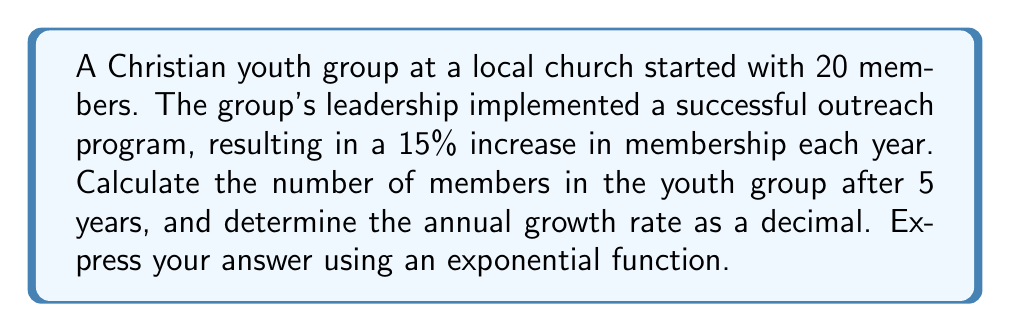Help me with this question. To solve this problem, we'll use an exponential growth function and follow these steps:

1. Identify the components of the exponential growth function:
   $A = P(1 + r)^t$
   Where:
   $A$ = Final amount
   $P$ = Initial principal (starting amount)
   $r$ = Annual growth rate (as a decimal)
   $t$ = Time in years

2. Fill in the known values:
   $P = 20$ (initial members)
   $r = 0.15$ (15% growth rate as a decimal)
   $t = 5$ (years)

3. Plug these values into the exponential growth function:
   $A = 20(1 + 0.15)^5$

4. Simplify:
   $A = 20(1.15)^5$

5. Calculate the result:
   $A = 20 * 2.0113689 \approx 40.23$ (rounded to two decimal places)

To express the answer using an exponential function, we keep it in the form:
$A = 20(1.15)^t$

Where $t$ represents the number of years since the program started.

The annual growth rate as a decimal is 0.15, which was given in the problem.
Answer: The number of members after 5 years: $A \approx 40.23$
The exponential function representing the growth: $A = 20(1.15)^t$
The annual growth rate as a decimal: $r = 0.15$ 